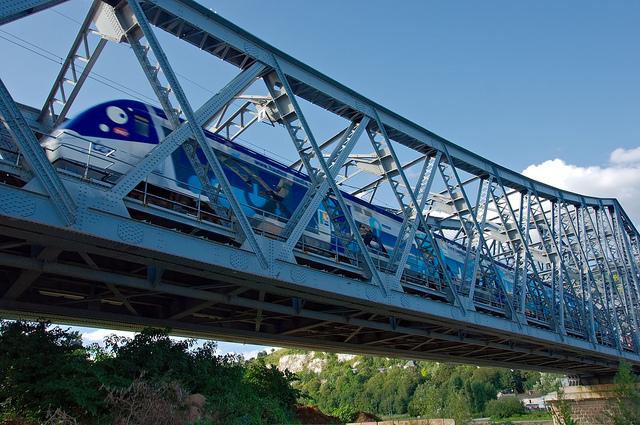How many trains are on the bridge?
Quick response, please. 1. How fast will the take you from one stop to the other?
Quick response, please. 5 minutes. Where is this station located?
Short answer required. Bridge. How many triangles are visible in this photo?
Quick response, please. 18. 